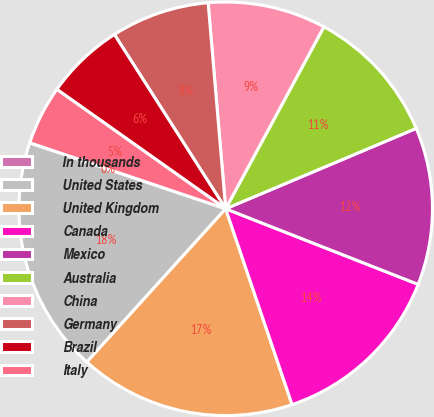Convert chart to OTSL. <chart><loc_0><loc_0><loc_500><loc_500><pie_chart><fcel>In thousands<fcel>United States<fcel>United Kingdom<fcel>Canada<fcel>Mexico<fcel>Australia<fcel>China<fcel>Germany<fcel>Brazil<fcel>Italy<nl><fcel>0.01%<fcel>18.45%<fcel>16.92%<fcel>13.84%<fcel>12.31%<fcel>10.77%<fcel>9.23%<fcel>7.69%<fcel>6.16%<fcel>4.62%<nl></chart> 